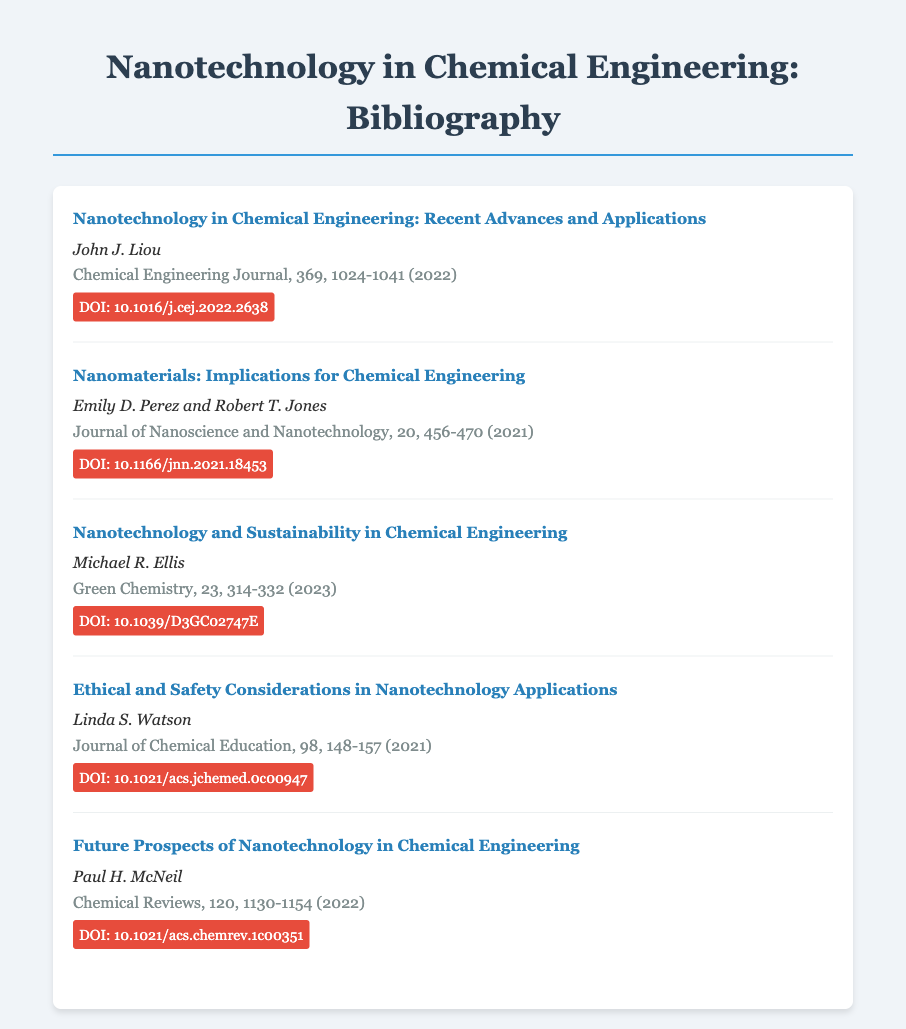What is the title of the first entry? The first entry's title is the specific name given to it in the document.
Answer: Nanotechnology in Chemical Engineering: Recent Advances and Applications Who is the author of the article about ethical considerations? The author of the article on ethical considerations is a specific individual mentioned in the document.
Answer: Linda S. Watson In which journal was the article by Paul H. McNeil published? The journal is the publication where the specific article appears, mentioned in the entry.
Answer: Chemical Reviews What year was the article on nanomaterials published? The year indicates when the specific article about nanomaterials was published, reflected in the citation.
Answer: 2021 What is the DOI of the article about sustainability? The DOI is a unique identifier that links to the specific article about sustainability, found in the document.
Answer: 10.1039/D3GC02747E How many entries are in the bibliography? The total number of entries is the count of individual articles cited within the document.
Answer: 5 Which author wrote about future prospects? The author of the article discussing future prospects is indicated in the citation for that entry.
Answer: Paul H. McNeil What volume and page numbers are associated with the article on nanotechnology and sustainability? The volume and page numbers provide specific details on where to find the article in the journal.
Answer: 23, 314-332 